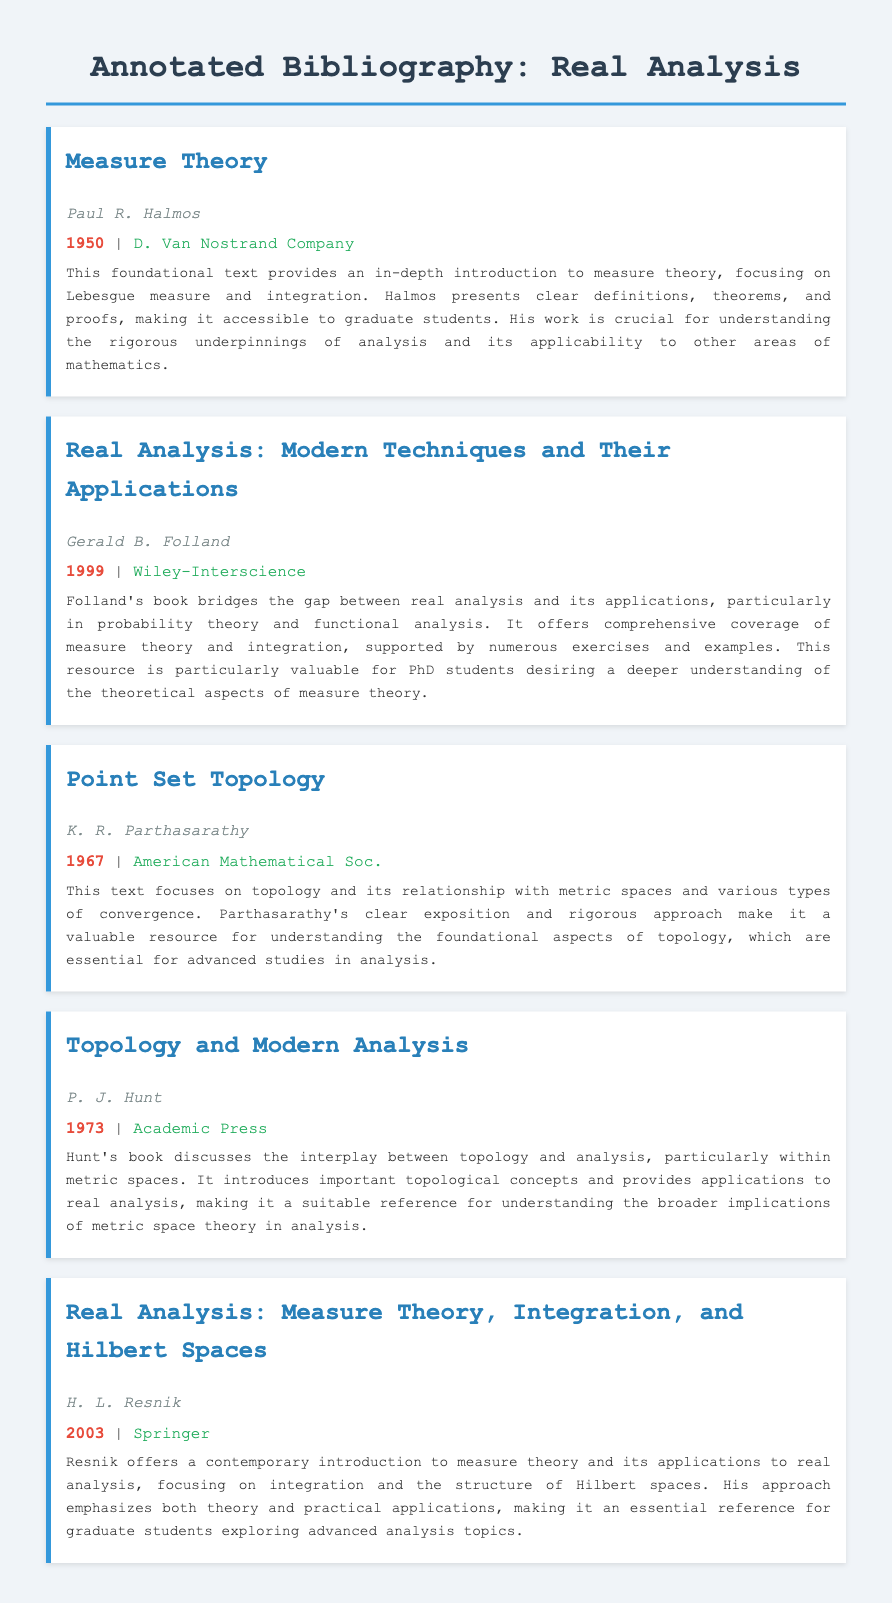What is the title of the first book listed? The title of the first book is clearly mentioned in the document.
Answer: Measure Theory Who is the author of the book "Real Analysis: Modern Techniques and Their Applications"? The document lists the authors of each book next to the titles.
Answer: Gerald B. Folland What year was "Point Set Topology" published? The publication year is provided in the document for each book.
Answer: 1967 Which publisher released the book by Paul R. Halmos? Each book includes the publisher information directly after the publication year.
Answer: D. Van Nostrand Company What is the primary focus of H. L. Resnik's book? The summary explicitly describes the main themes covered in this book.
Answer: Measure theory and integration What type of mathematics does P. J. Hunt's book relate to? The relationship is outlined in the summary, connecting topology and analysis.
Answer: Metric spaces What distinguishes Gerald B. Folland's book from others in the list? The summary highlights Folland's unique approach to bridging theory and applications.
Answer: Applications in probability theory and functional analysis Which book emphasizes advanced topics for graduate students? The summaries indicate which texts are aimed at graduate-level studies.
Answer: Real Analysis: Measure Theory, Integration, and Hilbert Spaces What year was "Topology and Modern Analysis" published? The publication year is directly stated in the document.
Answer: 1973 